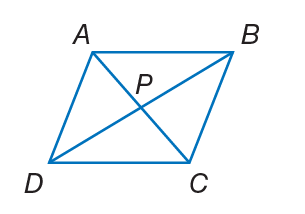Answer the mathemtical geometry problem and directly provide the correct option letter.
Question: A B C D is a rhombus. If P B = 12, A B = 15, and m \angle A B D = 24. Find C P.
Choices: A: 3 B: 6 C: 9 D: 15 C 